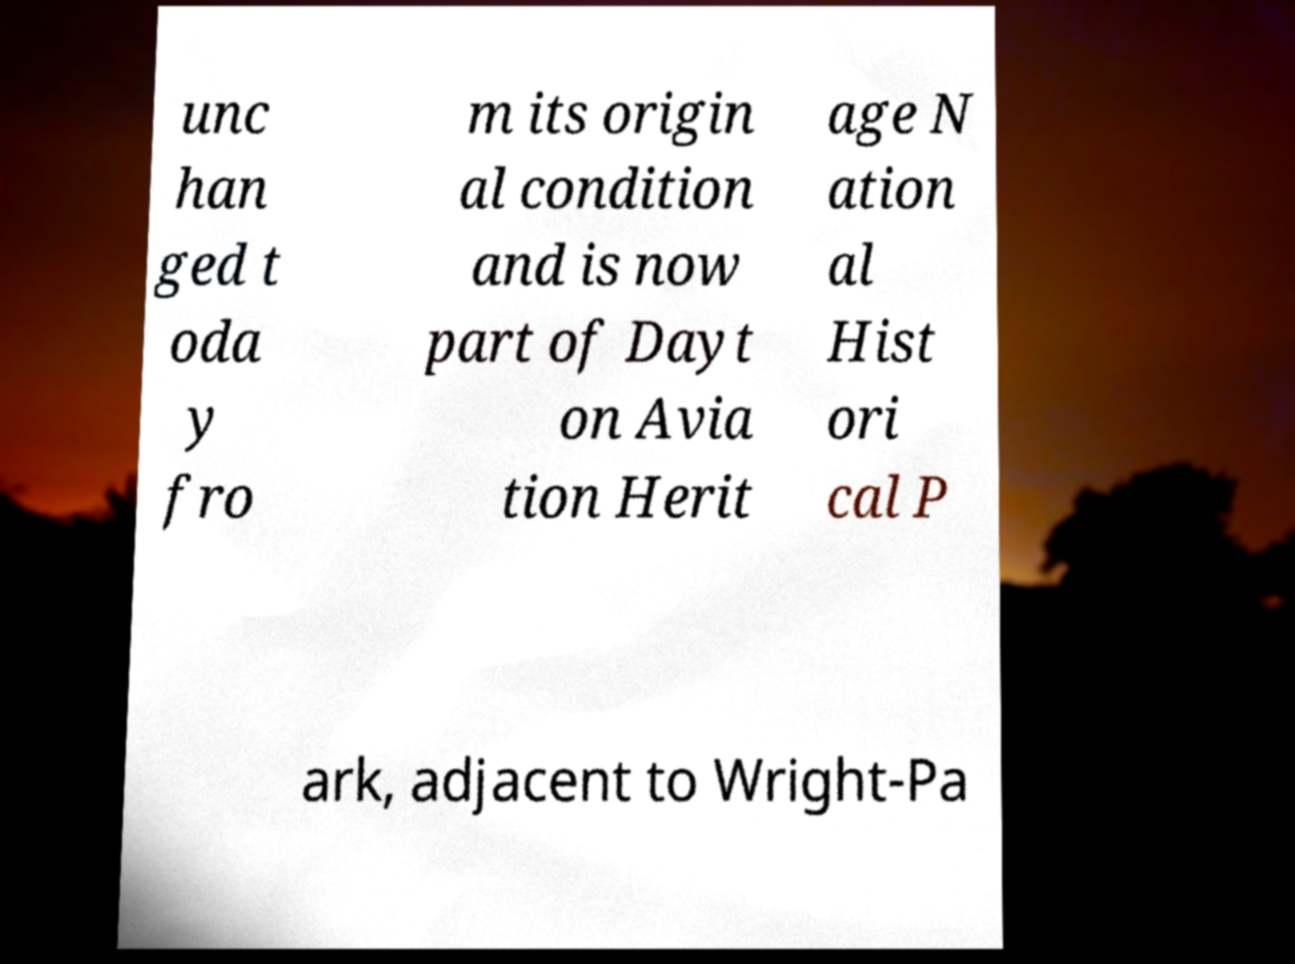I need the written content from this picture converted into text. Can you do that? unc han ged t oda y fro m its origin al condition and is now part of Dayt on Avia tion Herit age N ation al Hist ori cal P ark, adjacent to Wright-Pa 